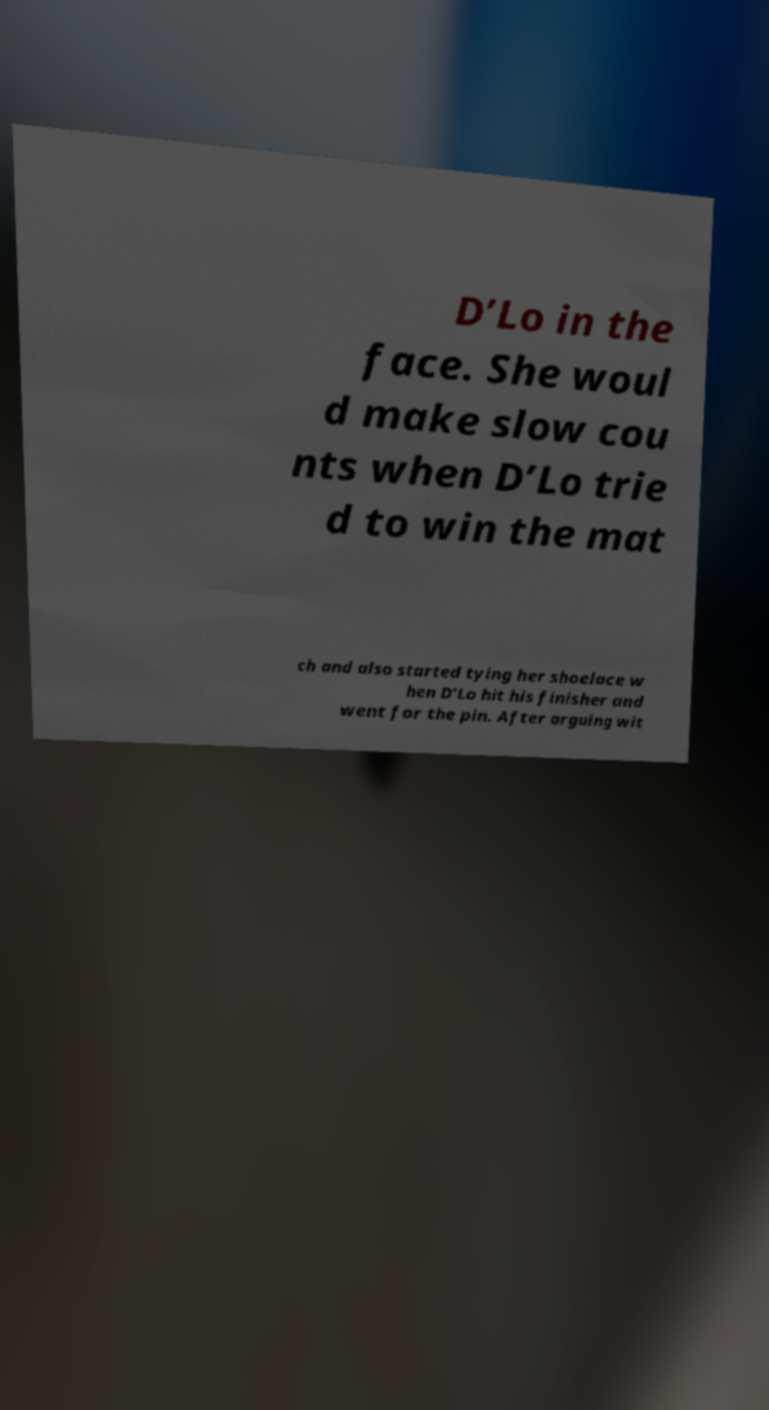For documentation purposes, I need the text within this image transcribed. Could you provide that? D’Lo in the face. She woul d make slow cou nts when D’Lo trie d to win the mat ch and also started tying her shoelace w hen D’Lo hit his finisher and went for the pin. After arguing wit 